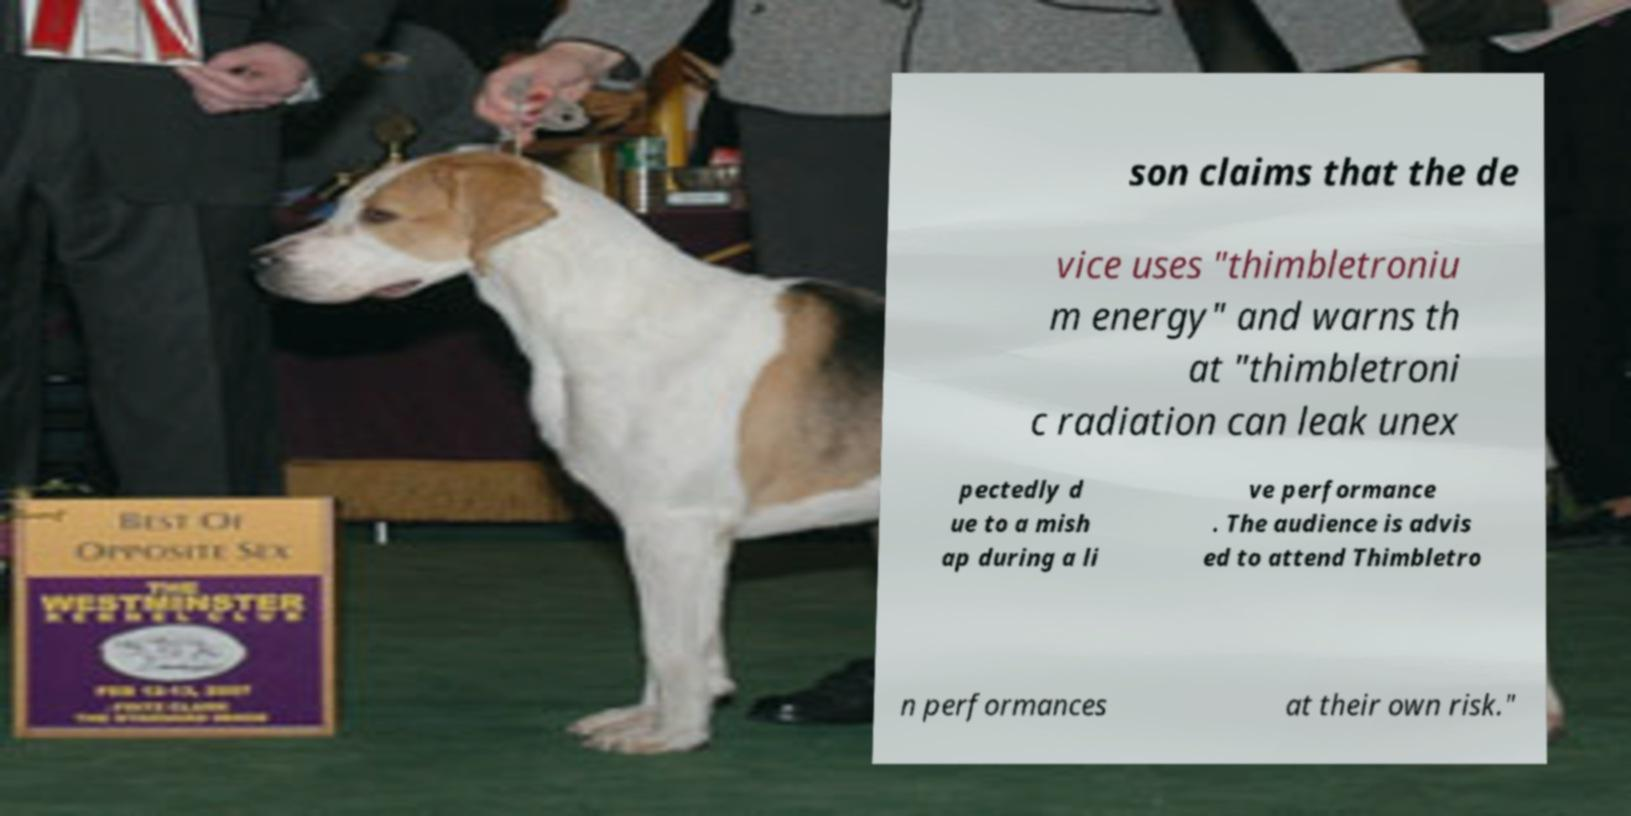Could you assist in decoding the text presented in this image and type it out clearly? son claims that the de vice uses "thimbletroniu m energy" and warns th at "thimbletroni c radiation can leak unex pectedly d ue to a mish ap during a li ve performance . The audience is advis ed to attend Thimbletro n performances at their own risk." 